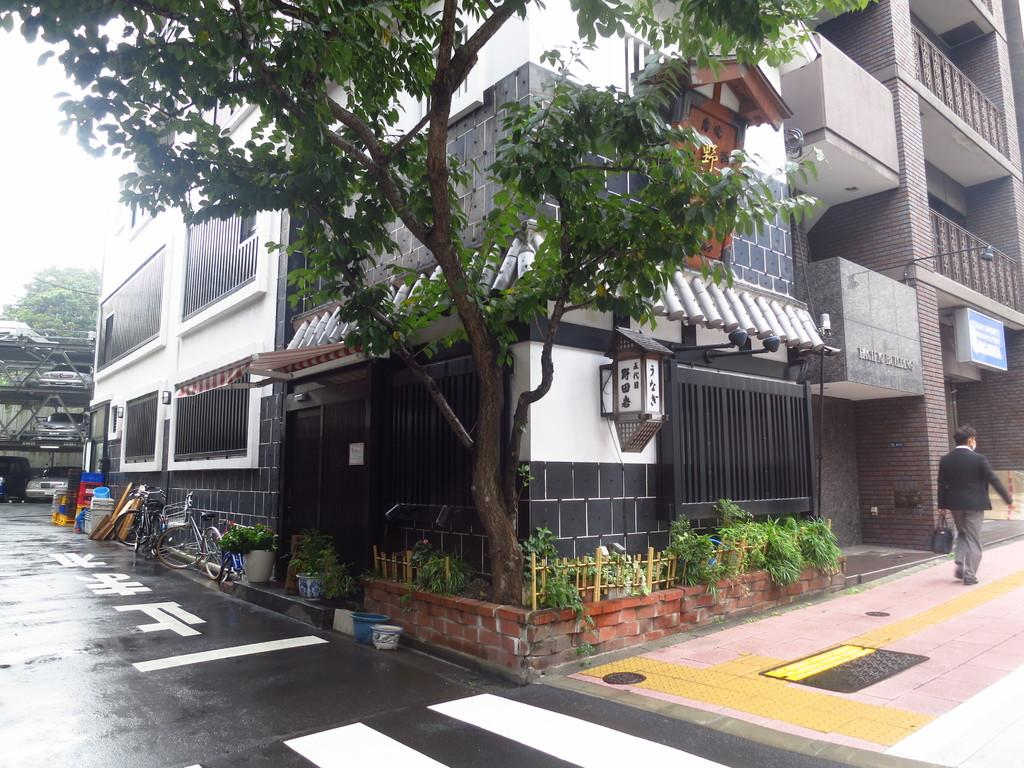What type of structures can be seen in the image? There are buildings in the image. What type of vegetation is present in the image? There are plants and trees in the image. What mode of transportation can be seen in the image? There are cycles and a car in the image. Can you describe any other objects in the image? There are other objects in the image, but their specific details are not mentioned in the provided facts. What is the person in the image doing? There is a person walking in the image. What note is the person playing on the plate in the image? There is no plate or note present in the image. Can you describe the person's toe in the image? There is no specific detail about the person's toe mentioned in the provided facts, and therefore it cannot be described. 